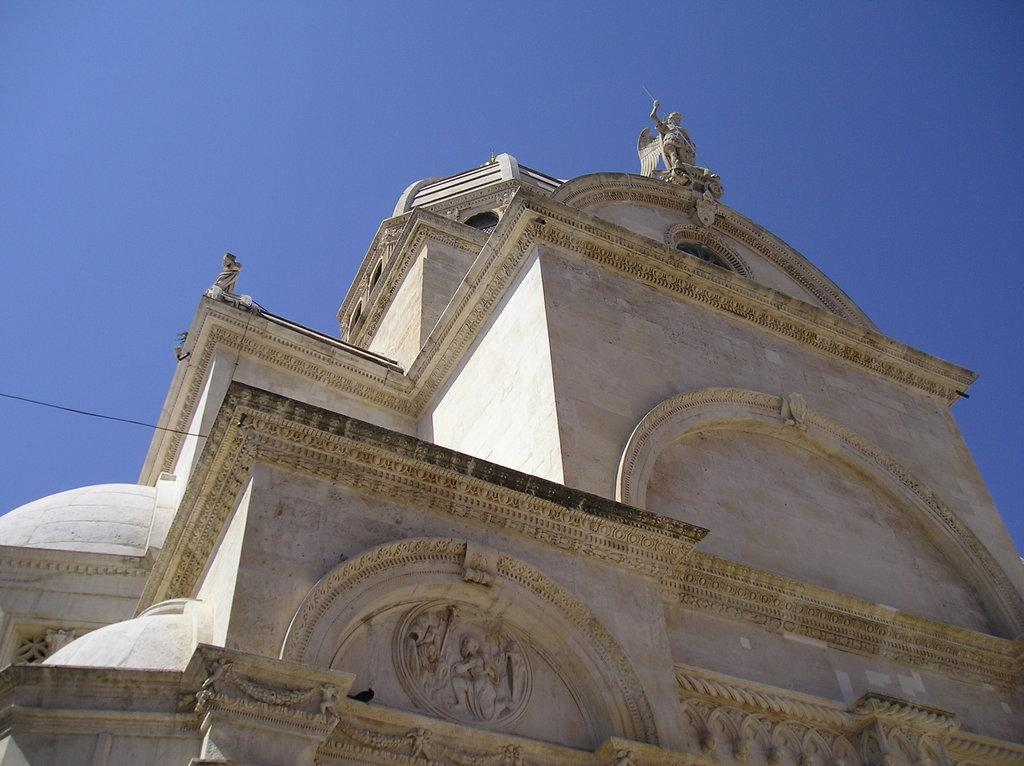What type of structure is present in the image? There is a building in the image. What can be seen at the top of the image? The sky is visible at the top of the image. What decorative elements are present on the building? There are sculptures on the building. How many brothers are depicted on the building in the image? There are no brothers depicted on the building in the image; it features sculptures, but they do not represent any specific individuals. 